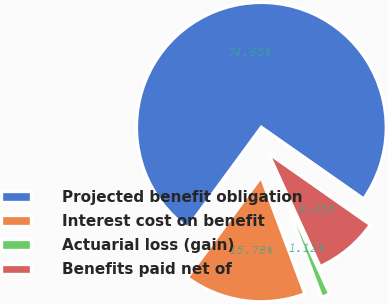<chart> <loc_0><loc_0><loc_500><loc_500><pie_chart><fcel>Projected benefit obligation<fcel>Interest cost on benefit<fcel>Actuarial loss (gain)<fcel>Benefits paid net of<nl><fcel>74.65%<fcel>15.78%<fcel>1.12%<fcel>8.45%<nl></chart> 